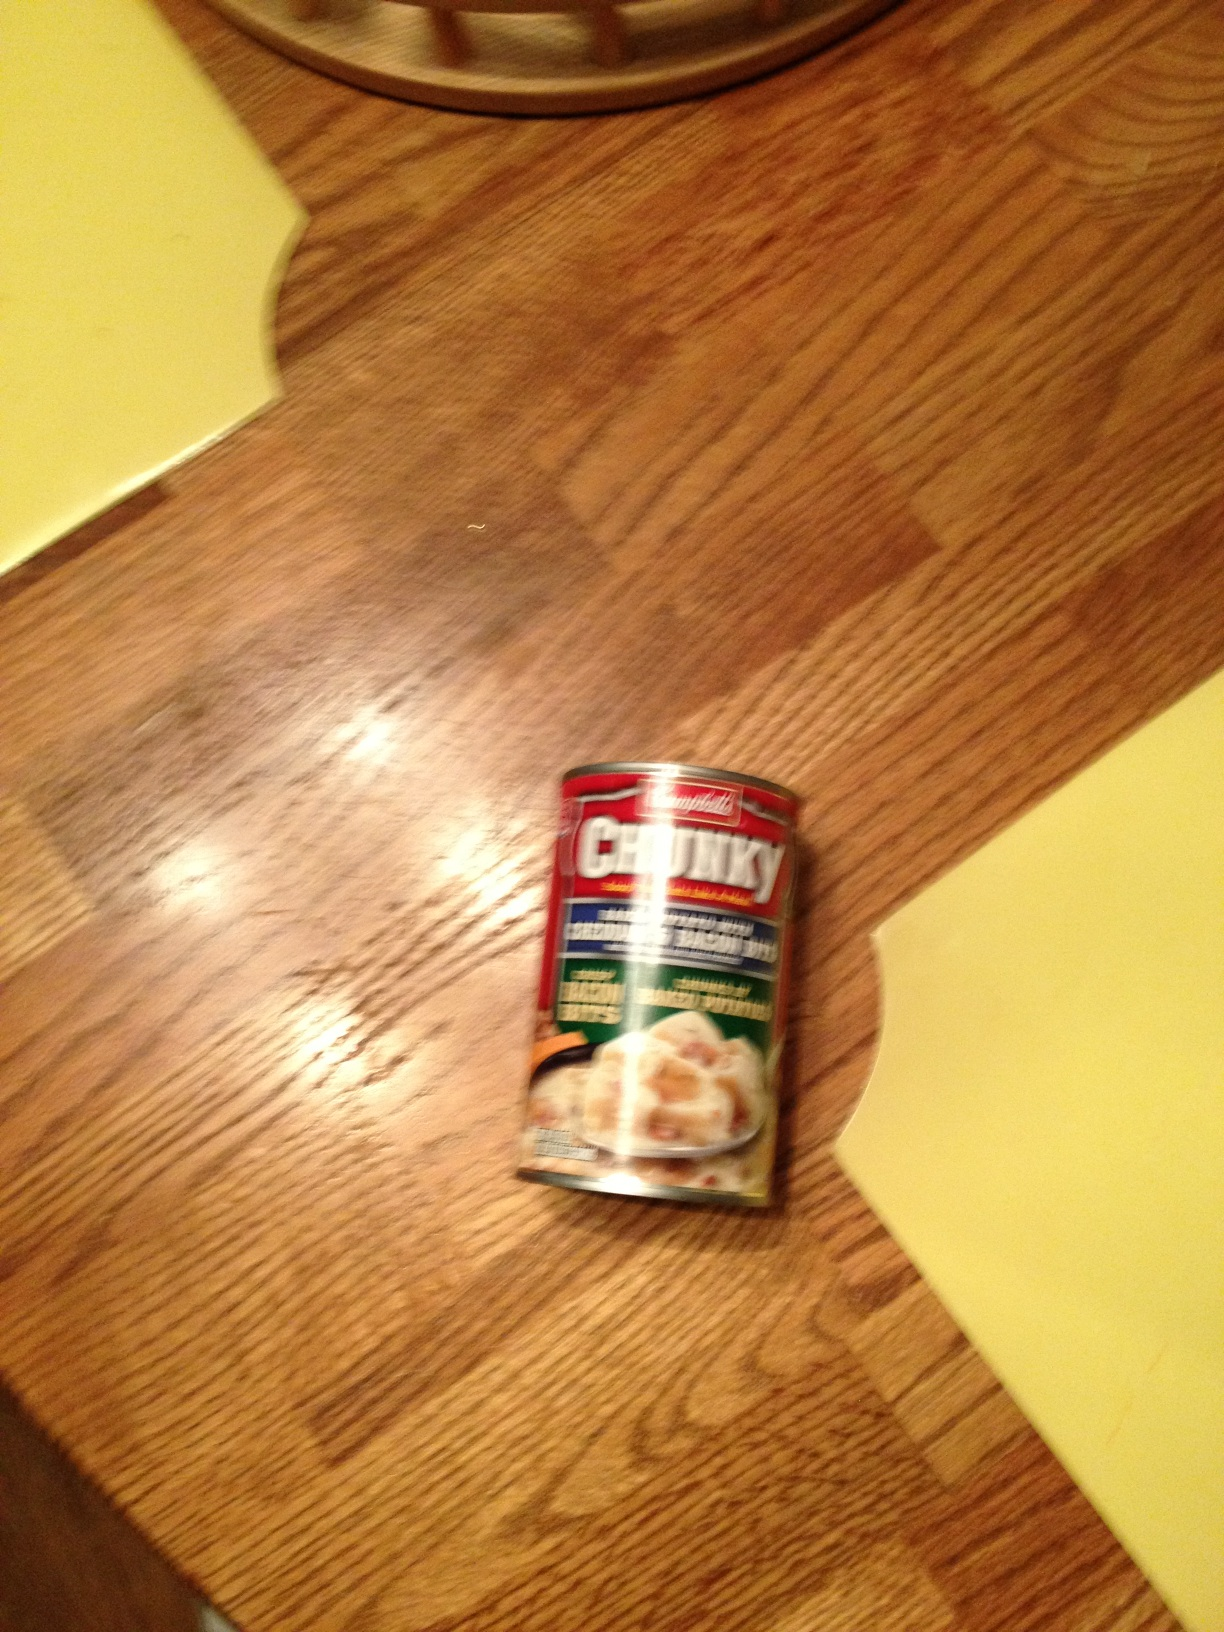What is this product? This is a can of Chunky canned soup, which is a hearty and convenient food option perfect for a quick meal. 